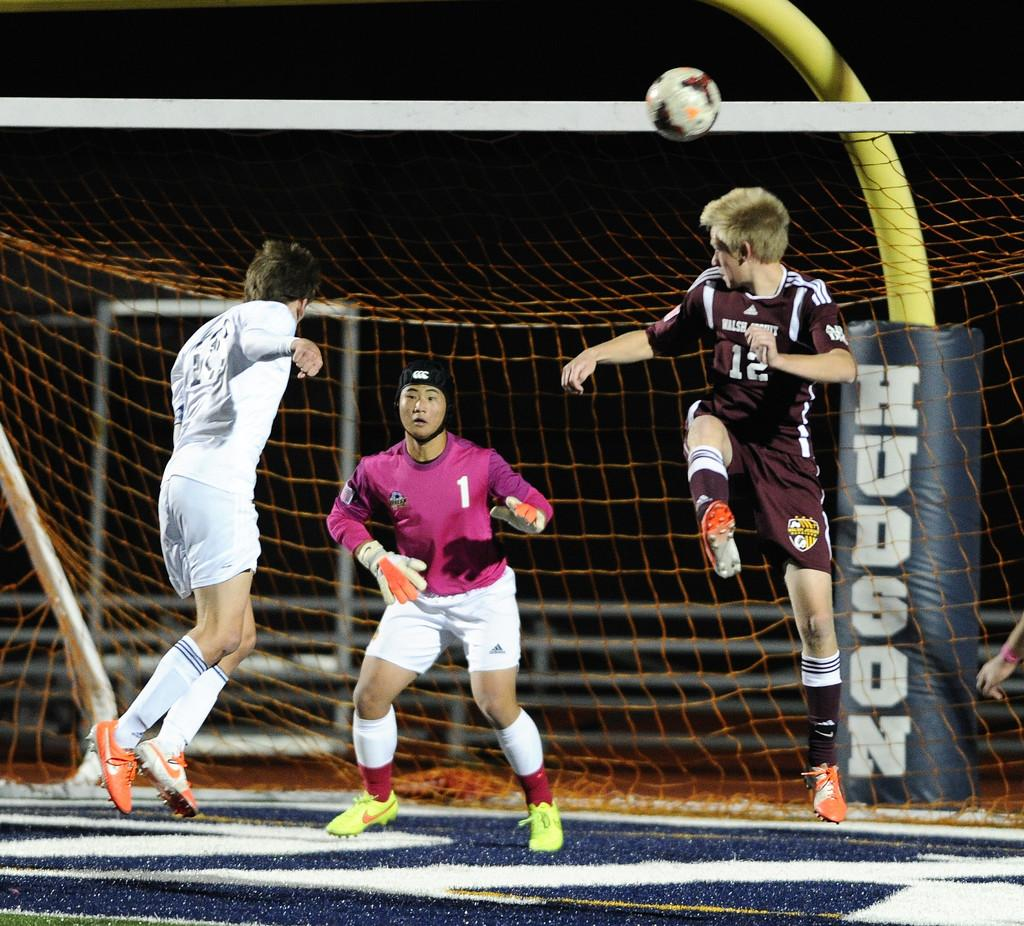<image>
Render a clear and concise summary of the photo. The goalkeeper wearing the number 1 looks for the soccer ball. 